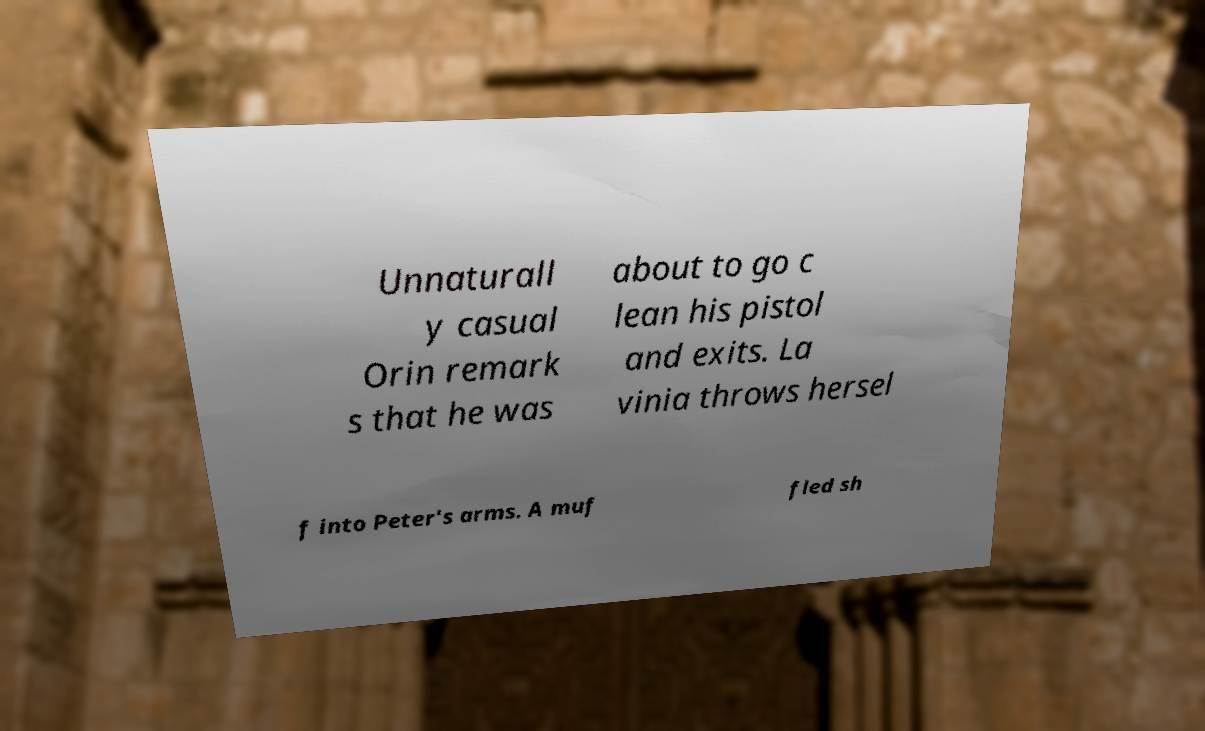For documentation purposes, I need the text within this image transcribed. Could you provide that? Unnaturall y casual Orin remark s that he was about to go c lean his pistol and exits. La vinia throws hersel f into Peter's arms. A muf fled sh 